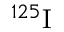Convert formula to latex. <formula><loc_0><loc_0><loc_500><loc_500>{ } ^ { 1 2 5 } I</formula> 